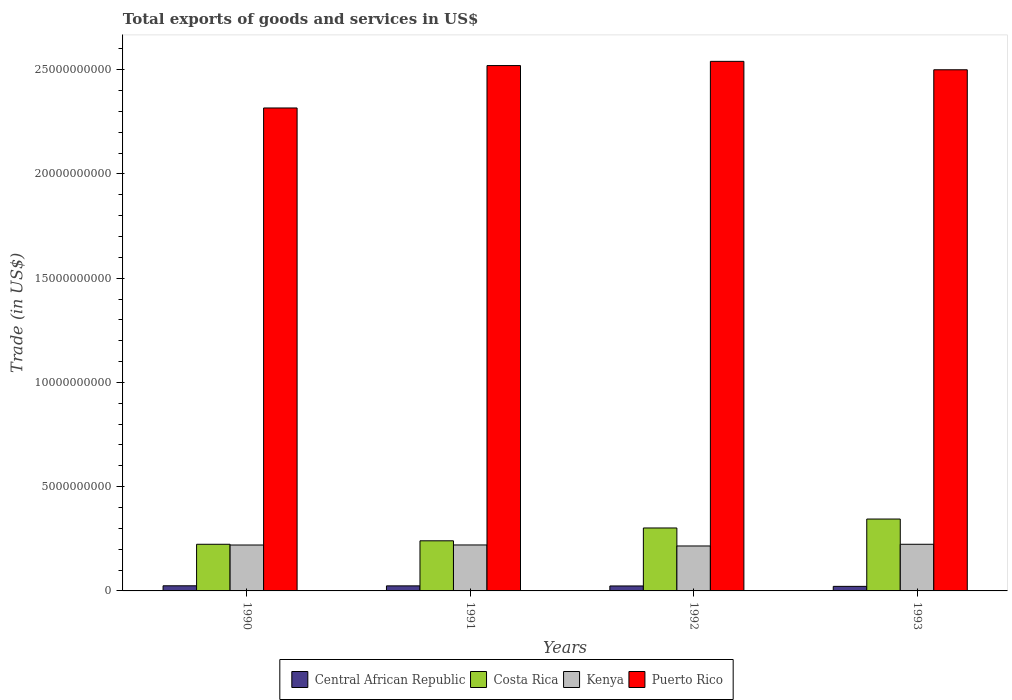How many groups of bars are there?
Your answer should be compact. 4. Are the number of bars on each tick of the X-axis equal?
Ensure brevity in your answer.  Yes. What is the total exports of goods and services in Costa Rica in 1990?
Ensure brevity in your answer.  2.24e+09. Across all years, what is the maximum total exports of goods and services in Costa Rica?
Keep it short and to the point. 3.45e+09. Across all years, what is the minimum total exports of goods and services in Puerto Rico?
Your answer should be compact. 2.32e+1. In which year was the total exports of goods and services in Central African Republic minimum?
Give a very brief answer. 1993. What is the total total exports of goods and services in Central African Republic in the graph?
Provide a short and direct response. 9.45e+08. What is the difference between the total exports of goods and services in Central African Republic in 1991 and that in 1993?
Provide a succinct answer. 2.36e+07. What is the difference between the total exports of goods and services in Puerto Rico in 1992 and the total exports of goods and services in Costa Rica in 1990?
Make the answer very short. 2.32e+1. What is the average total exports of goods and services in Puerto Rico per year?
Your answer should be compact. 2.47e+1. In the year 1990, what is the difference between the total exports of goods and services in Puerto Rico and total exports of goods and services in Kenya?
Your response must be concise. 2.10e+1. What is the ratio of the total exports of goods and services in Kenya in 1990 to that in 1993?
Ensure brevity in your answer.  0.98. Is the difference between the total exports of goods and services in Puerto Rico in 1992 and 1993 greater than the difference between the total exports of goods and services in Kenya in 1992 and 1993?
Ensure brevity in your answer.  Yes. What is the difference between the highest and the second highest total exports of goods and services in Costa Rica?
Offer a very short reply. 4.29e+08. What is the difference between the highest and the lowest total exports of goods and services in Costa Rica?
Your answer should be very brief. 1.21e+09. Is it the case that in every year, the sum of the total exports of goods and services in Central African Republic and total exports of goods and services in Kenya is greater than the sum of total exports of goods and services in Costa Rica and total exports of goods and services in Puerto Rico?
Your response must be concise. No. What does the 2nd bar from the left in 1993 represents?
Ensure brevity in your answer.  Costa Rica. What does the 2nd bar from the right in 1990 represents?
Give a very brief answer. Kenya. Is it the case that in every year, the sum of the total exports of goods and services in Central African Republic and total exports of goods and services in Costa Rica is greater than the total exports of goods and services in Puerto Rico?
Your answer should be compact. No. What is the difference between two consecutive major ticks on the Y-axis?
Your response must be concise. 5.00e+09. Are the values on the major ticks of Y-axis written in scientific E-notation?
Offer a terse response. No. Does the graph contain any zero values?
Keep it short and to the point. No. What is the title of the graph?
Offer a very short reply. Total exports of goods and services in US$. Does "Bermuda" appear as one of the legend labels in the graph?
Make the answer very short. No. What is the label or title of the Y-axis?
Your answer should be very brief. Trade (in US$). What is the Trade (in US$) in Central African Republic in 1990?
Keep it short and to the point. 2.46e+08. What is the Trade (in US$) in Costa Rica in 1990?
Your answer should be very brief. 2.24e+09. What is the Trade (in US$) of Kenya in 1990?
Provide a short and direct response. 2.20e+09. What is the Trade (in US$) in Puerto Rico in 1990?
Provide a short and direct response. 2.32e+1. What is the Trade (in US$) of Central African Republic in 1991?
Give a very brief answer. 2.42e+08. What is the Trade (in US$) in Costa Rica in 1991?
Your answer should be compact. 2.40e+09. What is the Trade (in US$) in Kenya in 1991?
Keep it short and to the point. 2.20e+09. What is the Trade (in US$) in Puerto Rico in 1991?
Provide a succinct answer. 2.52e+1. What is the Trade (in US$) in Central African Republic in 1992?
Offer a terse response. 2.38e+08. What is the Trade (in US$) in Costa Rica in 1992?
Ensure brevity in your answer.  3.02e+09. What is the Trade (in US$) in Kenya in 1992?
Your answer should be compact. 2.16e+09. What is the Trade (in US$) in Puerto Rico in 1992?
Make the answer very short. 2.54e+1. What is the Trade (in US$) in Central African Republic in 1993?
Your answer should be very brief. 2.19e+08. What is the Trade (in US$) in Costa Rica in 1993?
Provide a short and direct response. 3.45e+09. What is the Trade (in US$) in Kenya in 1993?
Offer a very short reply. 2.24e+09. What is the Trade (in US$) of Puerto Rico in 1993?
Give a very brief answer. 2.50e+1. Across all years, what is the maximum Trade (in US$) in Central African Republic?
Provide a succinct answer. 2.46e+08. Across all years, what is the maximum Trade (in US$) of Costa Rica?
Provide a succinct answer. 3.45e+09. Across all years, what is the maximum Trade (in US$) in Kenya?
Your response must be concise. 2.24e+09. Across all years, what is the maximum Trade (in US$) of Puerto Rico?
Offer a terse response. 2.54e+1. Across all years, what is the minimum Trade (in US$) in Central African Republic?
Give a very brief answer. 2.19e+08. Across all years, what is the minimum Trade (in US$) in Costa Rica?
Your answer should be compact. 2.24e+09. Across all years, what is the minimum Trade (in US$) of Kenya?
Offer a very short reply. 2.16e+09. Across all years, what is the minimum Trade (in US$) in Puerto Rico?
Give a very brief answer. 2.32e+1. What is the total Trade (in US$) in Central African Republic in the graph?
Make the answer very short. 9.45e+08. What is the total Trade (in US$) in Costa Rica in the graph?
Keep it short and to the point. 1.11e+1. What is the total Trade (in US$) of Kenya in the graph?
Provide a short and direct response. 8.80e+09. What is the total Trade (in US$) in Puerto Rico in the graph?
Offer a terse response. 9.88e+1. What is the difference between the Trade (in US$) in Central African Republic in 1990 and that in 1991?
Offer a terse response. 3.66e+06. What is the difference between the Trade (in US$) in Costa Rica in 1990 and that in 1991?
Offer a terse response. -1.67e+08. What is the difference between the Trade (in US$) of Kenya in 1990 and that in 1991?
Ensure brevity in your answer.  -1.83e+06. What is the difference between the Trade (in US$) in Puerto Rico in 1990 and that in 1991?
Offer a very short reply. -2.03e+09. What is the difference between the Trade (in US$) in Central African Republic in 1990 and that in 1992?
Offer a very short reply. 7.76e+06. What is the difference between the Trade (in US$) in Costa Rica in 1990 and that in 1992?
Make the answer very short. -7.82e+08. What is the difference between the Trade (in US$) in Kenya in 1990 and that in 1992?
Offer a very short reply. 4.67e+07. What is the difference between the Trade (in US$) of Puerto Rico in 1990 and that in 1992?
Make the answer very short. -2.24e+09. What is the difference between the Trade (in US$) of Central African Republic in 1990 and that in 1993?
Provide a short and direct response. 2.72e+07. What is the difference between the Trade (in US$) in Costa Rica in 1990 and that in 1993?
Ensure brevity in your answer.  -1.21e+09. What is the difference between the Trade (in US$) in Kenya in 1990 and that in 1993?
Keep it short and to the point. -3.52e+07. What is the difference between the Trade (in US$) in Puerto Rico in 1990 and that in 1993?
Provide a succinct answer. -1.83e+09. What is the difference between the Trade (in US$) in Central African Republic in 1991 and that in 1992?
Your answer should be very brief. 4.10e+06. What is the difference between the Trade (in US$) of Costa Rica in 1991 and that in 1992?
Your response must be concise. -6.16e+08. What is the difference between the Trade (in US$) of Kenya in 1991 and that in 1992?
Give a very brief answer. 4.85e+07. What is the difference between the Trade (in US$) of Puerto Rico in 1991 and that in 1992?
Give a very brief answer. -2.02e+08. What is the difference between the Trade (in US$) of Central African Republic in 1991 and that in 1993?
Your answer should be very brief. 2.36e+07. What is the difference between the Trade (in US$) in Costa Rica in 1991 and that in 1993?
Offer a very short reply. -1.04e+09. What is the difference between the Trade (in US$) in Kenya in 1991 and that in 1993?
Provide a succinct answer. -3.34e+07. What is the difference between the Trade (in US$) in Puerto Rico in 1991 and that in 1993?
Provide a short and direct response. 2.02e+08. What is the difference between the Trade (in US$) of Central African Republic in 1992 and that in 1993?
Offer a terse response. 1.95e+07. What is the difference between the Trade (in US$) of Costa Rica in 1992 and that in 1993?
Offer a very short reply. -4.29e+08. What is the difference between the Trade (in US$) of Kenya in 1992 and that in 1993?
Your answer should be very brief. -8.19e+07. What is the difference between the Trade (in US$) of Puerto Rico in 1992 and that in 1993?
Keep it short and to the point. 4.04e+08. What is the difference between the Trade (in US$) in Central African Republic in 1990 and the Trade (in US$) in Costa Rica in 1991?
Offer a very short reply. -2.16e+09. What is the difference between the Trade (in US$) in Central African Republic in 1990 and the Trade (in US$) in Kenya in 1991?
Your answer should be compact. -1.96e+09. What is the difference between the Trade (in US$) of Central African Republic in 1990 and the Trade (in US$) of Puerto Rico in 1991?
Offer a very short reply. -2.50e+1. What is the difference between the Trade (in US$) in Costa Rica in 1990 and the Trade (in US$) in Kenya in 1991?
Give a very brief answer. 3.29e+07. What is the difference between the Trade (in US$) in Costa Rica in 1990 and the Trade (in US$) in Puerto Rico in 1991?
Your answer should be compact. -2.30e+1. What is the difference between the Trade (in US$) in Kenya in 1990 and the Trade (in US$) in Puerto Rico in 1991?
Provide a succinct answer. -2.30e+1. What is the difference between the Trade (in US$) in Central African Republic in 1990 and the Trade (in US$) in Costa Rica in 1992?
Ensure brevity in your answer.  -2.77e+09. What is the difference between the Trade (in US$) in Central African Republic in 1990 and the Trade (in US$) in Kenya in 1992?
Your answer should be compact. -1.91e+09. What is the difference between the Trade (in US$) in Central African Republic in 1990 and the Trade (in US$) in Puerto Rico in 1992?
Provide a short and direct response. -2.52e+1. What is the difference between the Trade (in US$) in Costa Rica in 1990 and the Trade (in US$) in Kenya in 1992?
Provide a succinct answer. 8.15e+07. What is the difference between the Trade (in US$) in Costa Rica in 1990 and the Trade (in US$) in Puerto Rico in 1992?
Ensure brevity in your answer.  -2.32e+1. What is the difference between the Trade (in US$) in Kenya in 1990 and the Trade (in US$) in Puerto Rico in 1992?
Give a very brief answer. -2.32e+1. What is the difference between the Trade (in US$) in Central African Republic in 1990 and the Trade (in US$) in Costa Rica in 1993?
Offer a very short reply. -3.20e+09. What is the difference between the Trade (in US$) of Central African Republic in 1990 and the Trade (in US$) of Kenya in 1993?
Give a very brief answer. -1.99e+09. What is the difference between the Trade (in US$) in Central African Republic in 1990 and the Trade (in US$) in Puerto Rico in 1993?
Give a very brief answer. -2.47e+1. What is the difference between the Trade (in US$) of Costa Rica in 1990 and the Trade (in US$) of Kenya in 1993?
Offer a very short reply. -4.15e+05. What is the difference between the Trade (in US$) in Costa Rica in 1990 and the Trade (in US$) in Puerto Rico in 1993?
Offer a very short reply. -2.28e+1. What is the difference between the Trade (in US$) in Kenya in 1990 and the Trade (in US$) in Puerto Rico in 1993?
Offer a terse response. -2.28e+1. What is the difference between the Trade (in US$) of Central African Republic in 1991 and the Trade (in US$) of Costa Rica in 1992?
Make the answer very short. -2.78e+09. What is the difference between the Trade (in US$) in Central African Republic in 1991 and the Trade (in US$) in Kenya in 1992?
Your answer should be compact. -1.91e+09. What is the difference between the Trade (in US$) of Central African Republic in 1991 and the Trade (in US$) of Puerto Rico in 1992?
Provide a succinct answer. -2.52e+1. What is the difference between the Trade (in US$) of Costa Rica in 1991 and the Trade (in US$) of Kenya in 1992?
Give a very brief answer. 2.48e+08. What is the difference between the Trade (in US$) of Costa Rica in 1991 and the Trade (in US$) of Puerto Rico in 1992?
Keep it short and to the point. -2.30e+1. What is the difference between the Trade (in US$) in Kenya in 1991 and the Trade (in US$) in Puerto Rico in 1992?
Make the answer very short. -2.32e+1. What is the difference between the Trade (in US$) in Central African Republic in 1991 and the Trade (in US$) in Costa Rica in 1993?
Your answer should be very brief. -3.21e+09. What is the difference between the Trade (in US$) in Central African Republic in 1991 and the Trade (in US$) in Kenya in 1993?
Offer a very short reply. -2.00e+09. What is the difference between the Trade (in US$) in Central African Republic in 1991 and the Trade (in US$) in Puerto Rico in 1993?
Provide a succinct answer. -2.48e+1. What is the difference between the Trade (in US$) in Costa Rica in 1991 and the Trade (in US$) in Kenya in 1993?
Keep it short and to the point. 1.66e+08. What is the difference between the Trade (in US$) of Costa Rica in 1991 and the Trade (in US$) of Puerto Rico in 1993?
Provide a short and direct response. -2.26e+1. What is the difference between the Trade (in US$) of Kenya in 1991 and the Trade (in US$) of Puerto Rico in 1993?
Your response must be concise. -2.28e+1. What is the difference between the Trade (in US$) in Central African Republic in 1992 and the Trade (in US$) in Costa Rica in 1993?
Your answer should be very brief. -3.21e+09. What is the difference between the Trade (in US$) of Central African Republic in 1992 and the Trade (in US$) of Kenya in 1993?
Provide a short and direct response. -2.00e+09. What is the difference between the Trade (in US$) of Central African Republic in 1992 and the Trade (in US$) of Puerto Rico in 1993?
Offer a very short reply. -2.48e+1. What is the difference between the Trade (in US$) in Costa Rica in 1992 and the Trade (in US$) in Kenya in 1993?
Ensure brevity in your answer.  7.82e+08. What is the difference between the Trade (in US$) in Costa Rica in 1992 and the Trade (in US$) in Puerto Rico in 1993?
Make the answer very short. -2.20e+1. What is the difference between the Trade (in US$) of Kenya in 1992 and the Trade (in US$) of Puerto Rico in 1993?
Your answer should be very brief. -2.28e+1. What is the average Trade (in US$) in Central African Republic per year?
Provide a succinct answer. 2.36e+08. What is the average Trade (in US$) of Costa Rica per year?
Give a very brief answer. 2.78e+09. What is the average Trade (in US$) in Kenya per year?
Offer a very short reply. 2.20e+09. What is the average Trade (in US$) of Puerto Rico per year?
Make the answer very short. 2.47e+1. In the year 1990, what is the difference between the Trade (in US$) in Central African Republic and Trade (in US$) in Costa Rica?
Your answer should be compact. -1.99e+09. In the year 1990, what is the difference between the Trade (in US$) of Central African Republic and Trade (in US$) of Kenya?
Offer a very short reply. -1.96e+09. In the year 1990, what is the difference between the Trade (in US$) in Central African Republic and Trade (in US$) in Puerto Rico?
Provide a succinct answer. -2.29e+1. In the year 1990, what is the difference between the Trade (in US$) of Costa Rica and Trade (in US$) of Kenya?
Provide a succinct answer. 3.48e+07. In the year 1990, what is the difference between the Trade (in US$) of Costa Rica and Trade (in US$) of Puerto Rico?
Your answer should be compact. -2.09e+1. In the year 1990, what is the difference between the Trade (in US$) in Kenya and Trade (in US$) in Puerto Rico?
Give a very brief answer. -2.10e+1. In the year 1991, what is the difference between the Trade (in US$) in Central African Republic and Trade (in US$) in Costa Rica?
Make the answer very short. -2.16e+09. In the year 1991, what is the difference between the Trade (in US$) in Central African Republic and Trade (in US$) in Kenya?
Your answer should be very brief. -1.96e+09. In the year 1991, what is the difference between the Trade (in US$) in Central African Republic and Trade (in US$) in Puerto Rico?
Offer a terse response. -2.50e+1. In the year 1991, what is the difference between the Trade (in US$) in Costa Rica and Trade (in US$) in Kenya?
Provide a short and direct response. 2.00e+08. In the year 1991, what is the difference between the Trade (in US$) of Costa Rica and Trade (in US$) of Puerto Rico?
Your answer should be compact. -2.28e+1. In the year 1991, what is the difference between the Trade (in US$) in Kenya and Trade (in US$) in Puerto Rico?
Provide a short and direct response. -2.30e+1. In the year 1992, what is the difference between the Trade (in US$) in Central African Republic and Trade (in US$) in Costa Rica?
Provide a succinct answer. -2.78e+09. In the year 1992, what is the difference between the Trade (in US$) in Central African Republic and Trade (in US$) in Kenya?
Provide a succinct answer. -1.92e+09. In the year 1992, what is the difference between the Trade (in US$) of Central African Republic and Trade (in US$) of Puerto Rico?
Ensure brevity in your answer.  -2.52e+1. In the year 1992, what is the difference between the Trade (in US$) of Costa Rica and Trade (in US$) of Kenya?
Your answer should be compact. 8.64e+08. In the year 1992, what is the difference between the Trade (in US$) of Costa Rica and Trade (in US$) of Puerto Rico?
Make the answer very short. -2.24e+1. In the year 1992, what is the difference between the Trade (in US$) in Kenya and Trade (in US$) in Puerto Rico?
Your answer should be compact. -2.32e+1. In the year 1993, what is the difference between the Trade (in US$) of Central African Republic and Trade (in US$) of Costa Rica?
Your answer should be compact. -3.23e+09. In the year 1993, what is the difference between the Trade (in US$) of Central African Republic and Trade (in US$) of Kenya?
Your answer should be very brief. -2.02e+09. In the year 1993, what is the difference between the Trade (in US$) in Central African Republic and Trade (in US$) in Puerto Rico?
Your answer should be very brief. -2.48e+1. In the year 1993, what is the difference between the Trade (in US$) in Costa Rica and Trade (in US$) in Kenya?
Provide a short and direct response. 1.21e+09. In the year 1993, what is the difference between the Trade (in US$) of Costa Rica and Trade (in US$) of Puerto Rico?
Ensure brevity in your answer.  -2.15e+1. In the year 1993, what is the difference between the Trade (in US$) of Kenya and Trade (in US$) of Puerto Rico?
Provide a short and direct response. -2.28e+1. What is the ratio of the Trade (in US$) in Central African Republic in 1990 to that in 1991?
Give a very brief answer. 1.02. What is the ratio of the Trade (in US$) in Costa Rica in 1990 to that in 1991?
Ensure brevity in your answer.  0.93. What is the ratio of the Trade (in US$) of Puerto Rico in 1990 to that in 1991?
Your answer should be very brief. 0.92. What is the ratio of the Trade (in US$) in Central African Republic in 1990 to that in 1992?
Provide a short and direct response. 1.03. What is the ratio of the Trade (in US$) in Costa Rica in 1990 to that in 1992?
Provide a succinct answer. 0.74. What is the ratio of the Trade (in US$) in Kenya in 1990 to that in 1992?
Offer a very short reply. 1.02. What is the ratio of the Trade (in US$) of Puerto Rico in 1990 to that in 1992?
Offer a very short reply. 0.91. What is the ratio of the Trade (in US$) of Central African Republic in 1990 to that in 1993?
Give a very brief answer. 1.12. What is the ratio of the Trade (in US$) of Costa Rica in 1990 to that in 1993?
Provide a short and direct response. 0.65. What is the ratio of the Trade (in US$) of Kenya in 1990 to that in 1993?
Provide a succinct answer. 0.98. What is the ratio of the Trade (in US$) in Puerto Rico in 1990 to that in 1993?
Make the answer very short. 0.93. What is the ratio of the Trade (in US$) in Central African Republic in 1991 to that in 1992?
Offer a very short reply. 1.02. What is the ratio of the Trade (in US$) of Costa Rica in 1991 to that in 1992?
Provide a short and direct response. 0.8. What is the ratio of the Trade (in US$) in Kenya in 1991 to that in 1992?
Your response must be concise. 1.02. What is the ratio of the Trade (in US$) in Puerto Rico in 1991 to that in 1992?
Make the answer very short. 0.99. What is the ratio of the Trade (in US$) of Central African Republic in 1991 to that in 1993?
Your answer should be very brief. 1.11. What is the ratio of the Trade (in US$) in Costa Rica in 1991 to that in 1993?
Make the answer very short. 0.7. What is the ratio of the Trade (in US$) of Kenya in 1991 to that in 1993?
Your response must be concise. 0.99. What is the ratio of the Trade (in US$) of Central African Republic in 1992 to that in 1993?
Provide a short and direct response. 1.09. What is the ratio of the Trade (in US$) in Costa Rica in 1992 to that in 1993?
Provide a succinct answer. 0.88. What is the ratio of the Trade (in US$) of Kenya in 1992 to that in 1993?
Offer a very short reply. 0.96. What is the ratio of the Trade (in US$) of Puerto Rico in 1992 to that in 1993?
Make the answer very short. 1.02. What is the difference between the highest and the second highest Trade (in US$) in Central African Republic?
Offer a terse response. 3.66e+06. What is the difference between the highest and the second highest Trade (in US$) in Costa Rica?
Keep it short and to the point. 4.29e+08. What is the difference between the highest and the second highest Trade (in US$) of Kenya?
Your answer should be compact. 3.34e+07. What is the difference between the highest and the second highest Trade (in US$) of Puerto Rico?
Your answer should be very brief. 2.02e+08. What is the difference between the highest and the lowest Trade (in US$) of Central African Republic?
Provide a succinct answer. 2.72e+07. What is the difference between the highest and the lowest Trade (in US$) of Costa Rica?
Offer a very short reply. 1.21e+09. What is the difference between the highest and the lowest Trade (in US$) of Kenya?
Give a very brief answer. 8.19e+07. What is the difference between the highest and the lowest Trade (in US$) of Puerto Rico?
Ensure brevity in your answer.  2.24e+09. 